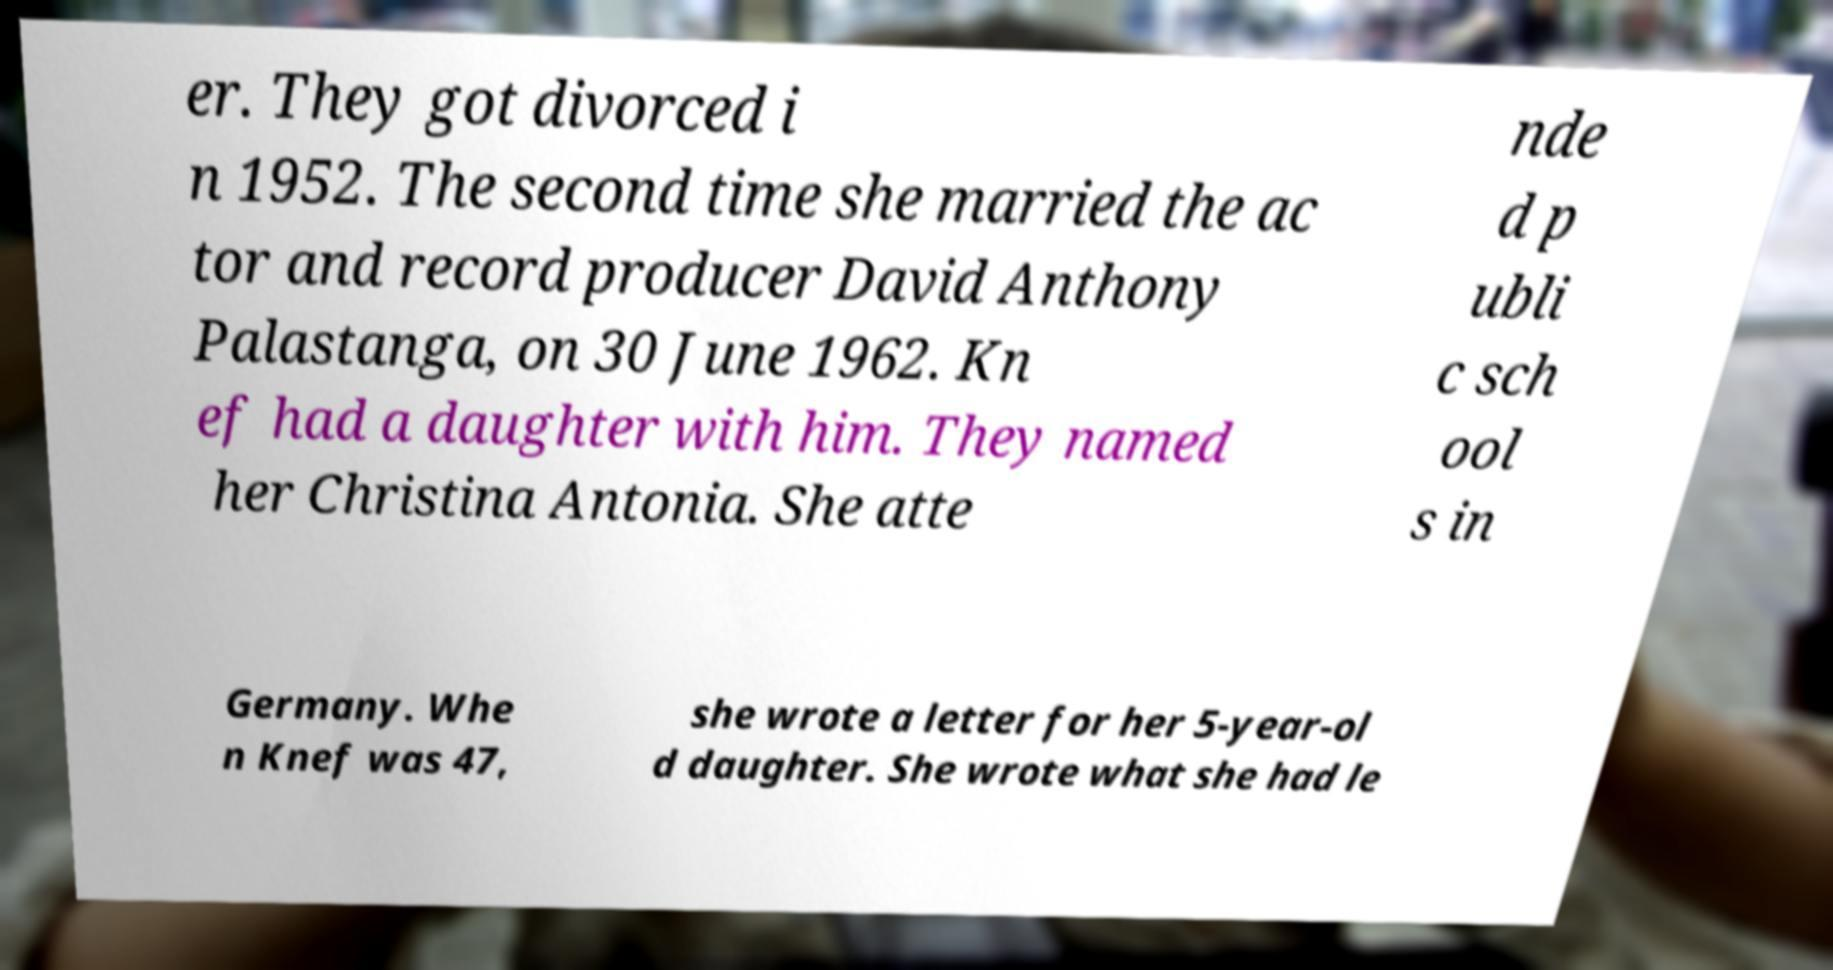For documentation purposes, I need the text within this image transcribed. Could you provide that? er. They got divorced i n 1952. The second time she married the ac tor and record producer David Anthony Palastanga, on 30 June 1962. Kn ef had a daughter with him. They named her Christina Antonia. She atte nde d p ubli c sch ool s in Germany. Whe n Knef was 47, she wrote a letter for her 5-year-ol d daughter. She wrote what she had le 